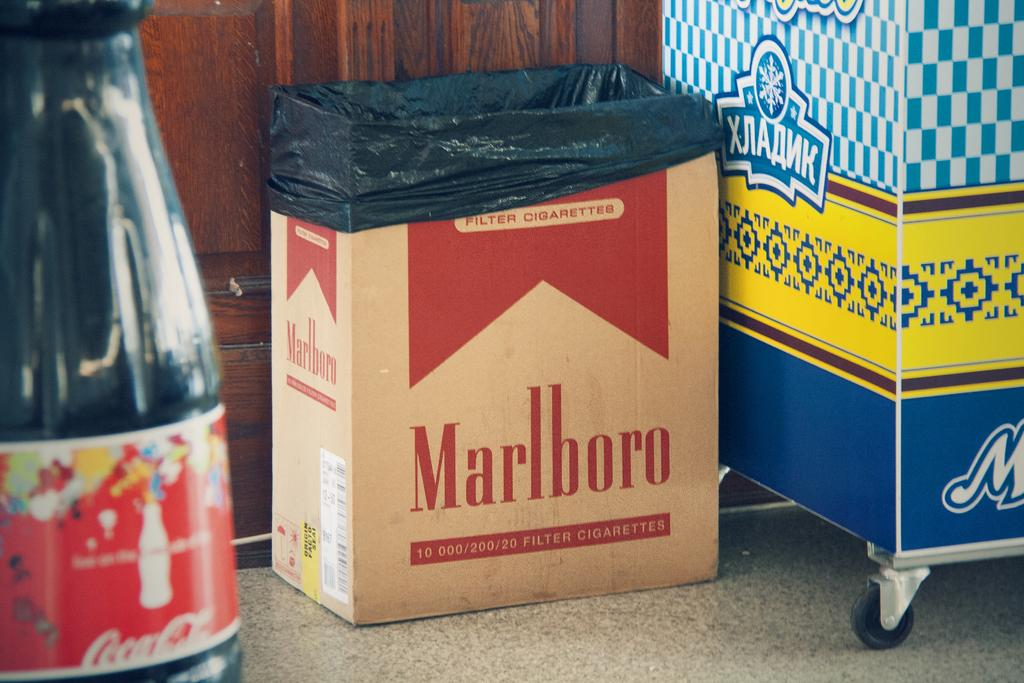Provide a one-sentence caption for the provided image. A cardboard box labeled with the Marlboro cigarette logo has a black trash bag in it. 